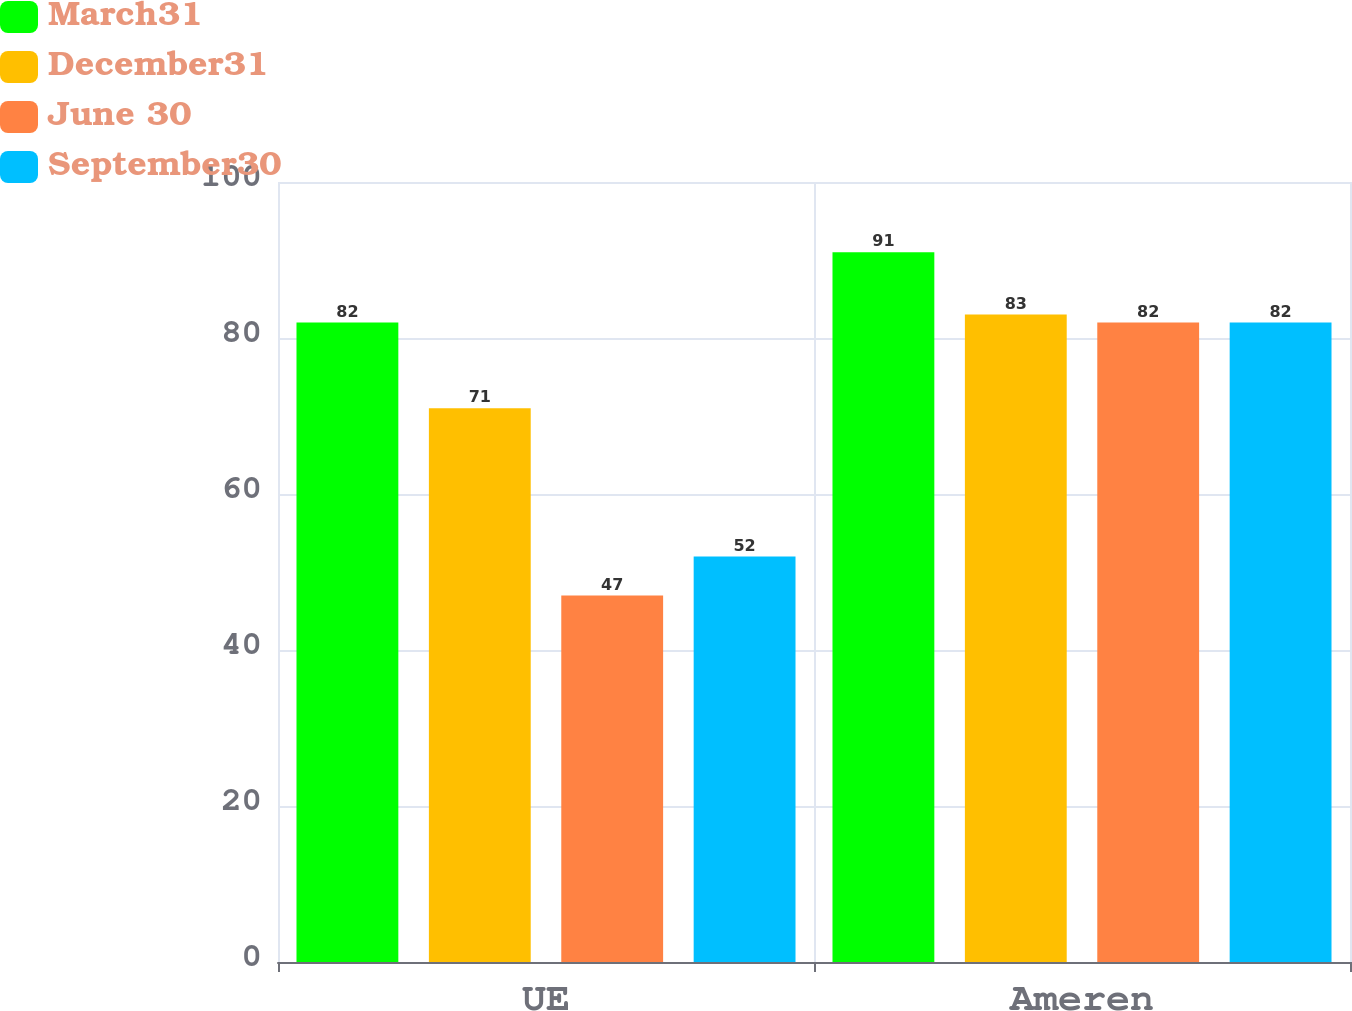Convert chart to OTSL. <chart><loc_0><loc_0><loc_500><loc_500><stacked_bar_chart><ecel><fcel>UE<fcel>Ameren<nl><fcel>March31<fcel>82<fcel>91<nl><fcel>December31<fcel>71<fcel>83<nl><fcel>June 30<fcel>47<fcel>82<nl><fcel>September30<fcel>52<fcel>82<nl></chart> 